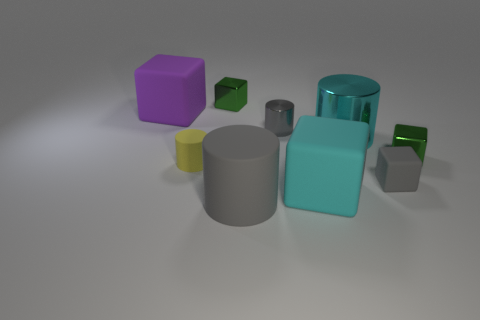What is the color of the small shiny cube left of the large gray cylinder?
Give a very brief answer. Green. How many things are either gray rubber things on the left side of the tiny metallic cylinder or rubber cylinders in front of the small gray cube?
Ensure brevity in your answer.  1. Do the purple cube and the cyan cube have the same size?
Offer a terse response. Yes. How many balls are gray things or big cyan matte objects?
Ensure brevity in your answer.  0. How many objects are behind the big cyan matte object and left of the small gray cylinder?
Your answer should be compact. 3. There is a cyan cylinder; is its size the same as the green object behind the purple rubber thing?
Your response must be concise. No. There is a small green metallic cube in front of the small block to the left of the large cyan matte object; are there any cubes on the right side of it?
Offer a terse response. No. The gray object behind the yellow thing that is in front of the cyan metal cylinder is made of what material?
Make the answer very short. Metal. There is a cylinder that is both in front of the big cyan shiny cylinder and on the right side of the tiny yellow thing; what material is it?
Make the answer very short. Rubber. Is there a yellow rubber object of the same shape as the cyan metal object?
Offer a terse response. Yes. 